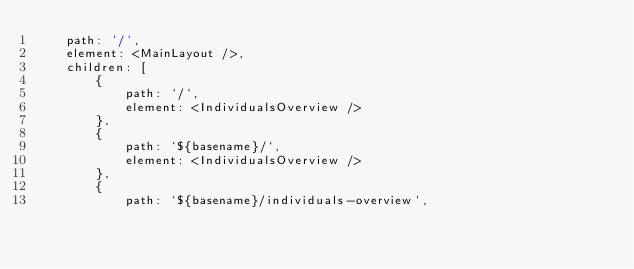Convert code to text. <code><loc_0><loc_0><loc_500><loc_500><_JavaScript_>    path: '/',
    element: <MainLayout />,
    children: [
        {
            path: `/`,
            element: <IndividualsOverview />
        },
        {
            path: `${basename}/`,
            element: <IndividualsOverview />
        },
        {
            path: `${basename}/individuals-overview`,</code> 